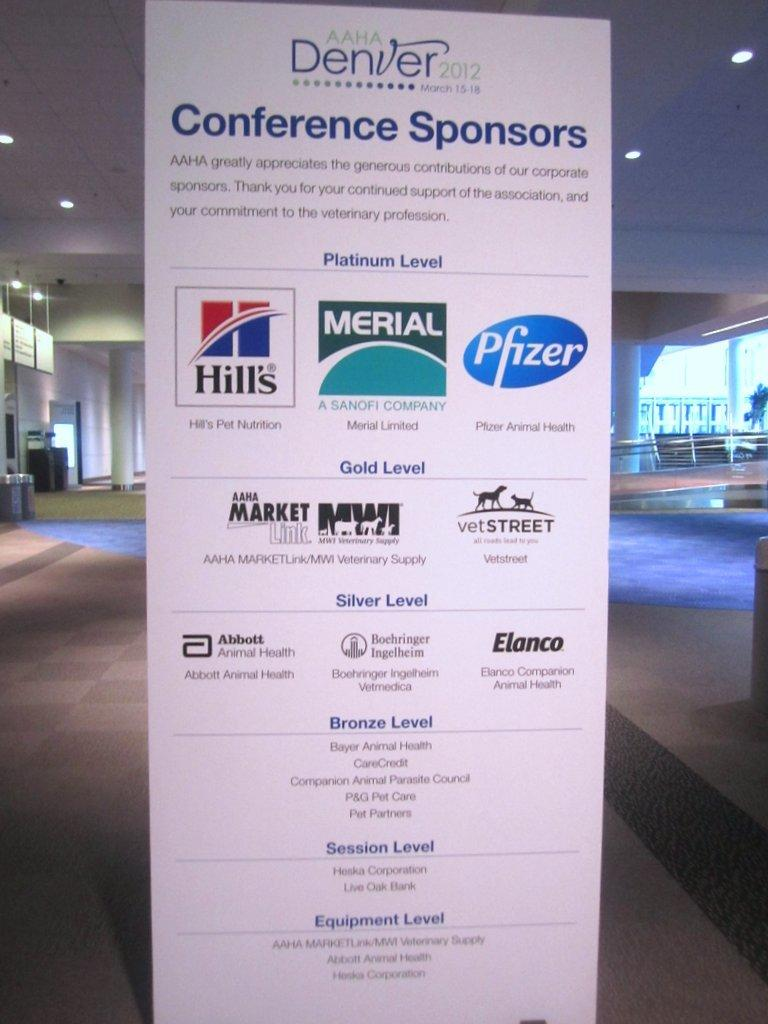Provide a one-sentence caption for the provided image. A sign with a list of conference sponsors sits in a lobby area. 